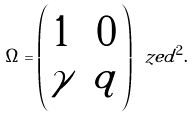Convert formula to latex. <formula><loc_0><loc_0><loc_500><loc_500>\Omega = \left ( \begin{matrix} 1 & 0 \\ \gamma & q \end{matrix} \right ) \ z e d ^ { 2 } .</formula> 